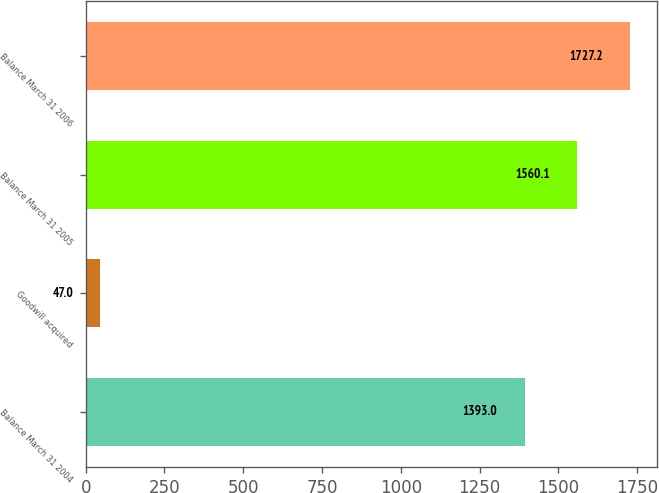<chart> <loc_0><loc_0><loc_500><loc_500><bar_chart><fcel>Balance March 31 2004<fcel>Goodwill acquired<fcel>Balance March 31 2005<fcel>Balance March 31 2006<nl><fcel>1393<fcel>47<fcel>1560.1<fcel>1727.2<nl></chart> 